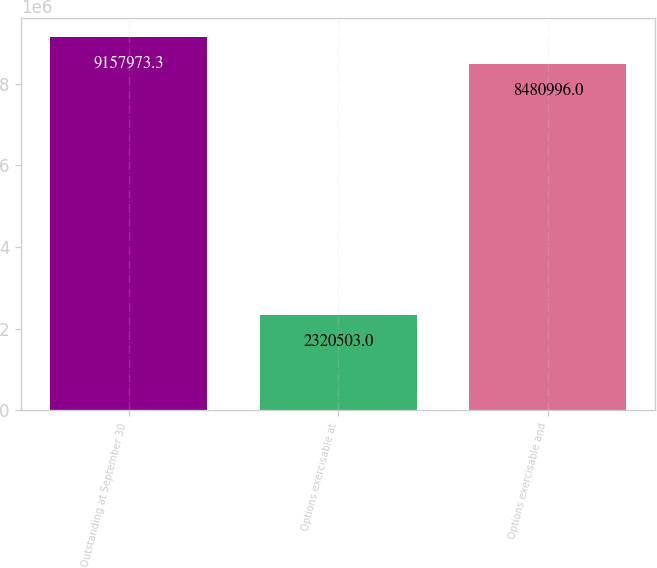Convert chart. <chart><loc_0><loc_0><loc_500><loc_500><bar_chart><fcel>Outstanding at September 30<fcel>Options exercisable at<fcel>Options exercisable and<nl><fcel>9.15797e+06<fcel>2.3205e+06<fcel>8.481e+06<nl></chart> 